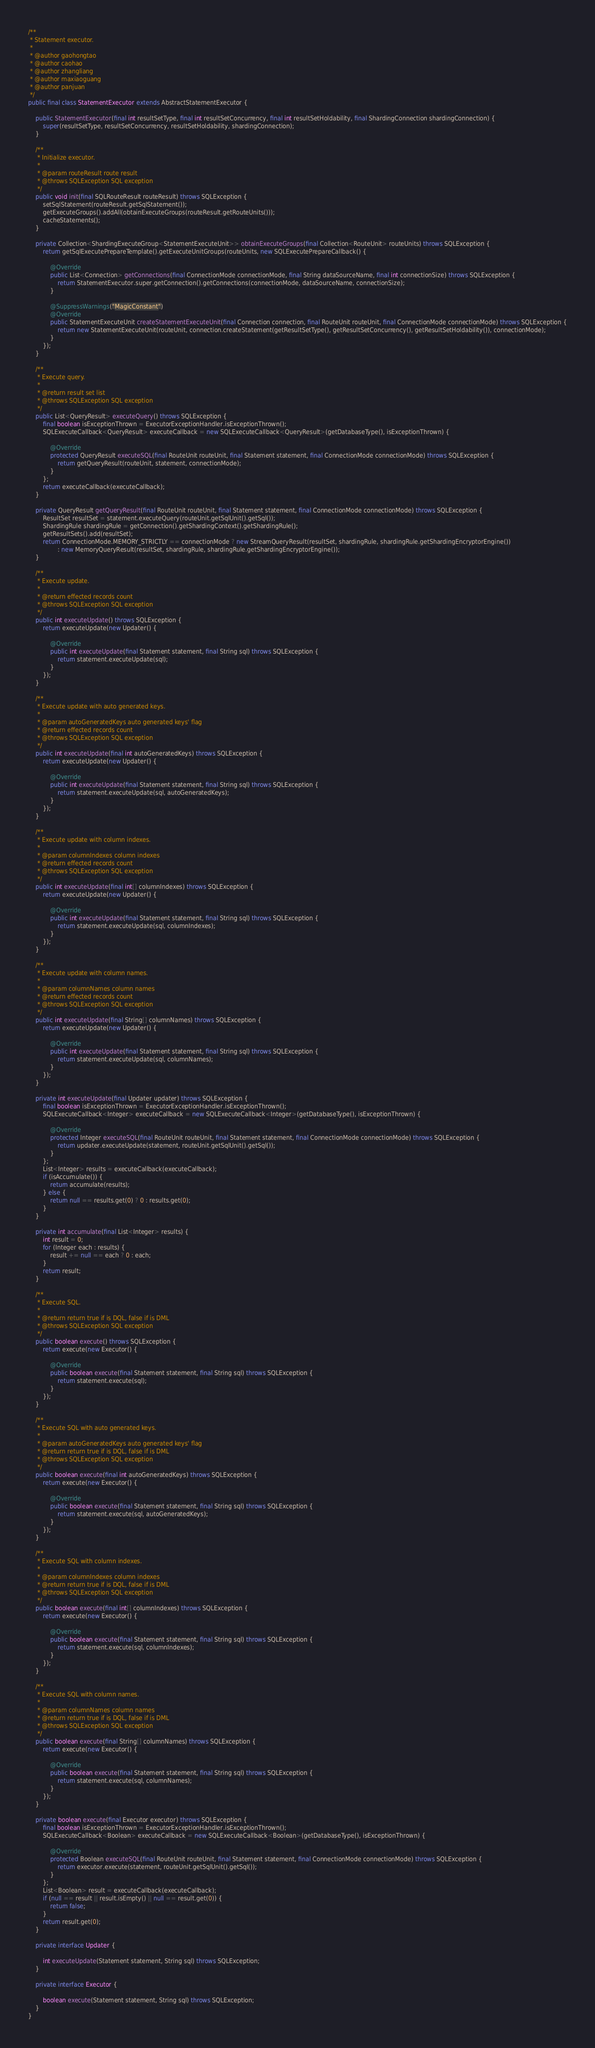<code> <loc_0><loc_0><loc_500><loc_500><_Java_>/**
 * Statement executor.
 * 
 * @author gaohongtao
 * @author caohao
 * @author zhangliang
 * @author maxiaoguang
 * @author panjuan
 */
public final class StatementExecutor extends AbstractStatementExecutor {
    
    public StatementExecutor(final int resultSetType, final int resultSetConcurrency, final int resultSetHoldability, final ShardingConnection shardingConnection) {
        super(resultSetType, resultSetConcurrency, resultSetHoldability, shardingConnection);
    }
    
    /**
     * Initialize executor.
     *
     * @param routeResult route result
     * @throws SQLException SQL exception
     */
    public void init(final SQLRouteResult routeResult) throws SQLException {
        setSqlStatement(routeResult.getSqlStatement());
        getExecuteGroups().addAll(obtainExecuteGroups(routeResult.getRouteUnits()));
        cacheStatements();
    }
    
    private Collection<ShardingExecuteGroup<StatementExecuteUnit>> obtainExecuteGroups(final Collection<RouteUnit> routeUnits) throws SQLException {
        return getSqlExecutePrepareTemplate().getExecuteUnitGroups(routeUnits, new SQLExecutePrepareCallback() {
            
            @Override
            public List<Connection> getConnections(final ConnectionMode connectionMode, final String dataSourceName, final int connectionSize) throws SQLException {
                return StatementExecutor.super.getConnection().getConnections(connectionMode, dataSourceName, connectionSize);
            }
    
            @SuppressWarnings("MagicConstant")
            @Override
            public StatementExecuteUnit createStatementExecuteUnit(final Connection connection, final RouteUnit routeUnit, final ConnectionMode connectionMode) throws SQLException {
                return new StatementExecuteUnit(routeUnit, connection.createStatement(getResultSetType(), getResultSetConcurrency(), getResultSetHoldability()), connectionMode);
            }
        });
    }
    
    /**
     * Execute query.
     * 
     * @return result set list
     * @throws SQLException SQL exception
     */
    public List<QueryResult> executeQuery() throws SQLException {
        final boolean isExceptionThrown = ExecutorExceptionHandler.isExceptionThrown();
        SQLExecuteCallback<QueryResult> executeCallback = new SQLExecuteCallback<QueryResult>(getDatabaseType(), isExceptionThrown) {
            
            @Override
            protected QueryResult executeSQL(final RouteUnit routeUnit, final Statement statement, final ConnectionMode connectionMode) throws SQLException {
                return getQueryResult(routeUnit, statement, connectionMode);
            }
        };
        return executeCallback(executeCallback);
    }
    
    private QueryResult getQueryResult(final RouteUnit routeUnit, final Statement statement, final ConnectionMode connectionMode) throws SQLException {
        ResultSet resultSet = statement.executeQuery(routeUnit.getSqlUnit().getSql());
        ShardingRule shardingRule = getConnection().getShardingContext().getShardingRule();
        getResultSets().add(resultSet);
        return ConnectionMode.MEMORY_STRICTLY == connectionMode ? new StreamQueryResult(resultSet, shardingRule, shardingRule.getShardingEncryptorEngine()) 
                : new MemoryQueryResult(resultSet, shardingRule, shardingRule.getShardingEncryptorEngine());
    }
    
    /**
     * Execute update.
     * 
     * @return effected records count
     * @throws SQLException SQL exception
     */
    public int executeUpdate() throws SQLException {
        return executeUpdate(new Updater() {
            
            @Override
            public int executeUpdate(final Statement statement, final String sql) throws SQLException {
                return statement.executeUpdate(sql);
            }
        });
    }
    
    /**
     * Execute update with auto generated keys.
     * 
     * @param autoGeneratedKeys auto generated keys' flag
     * @return effected records count
     * @throws SQLException SQL exception
     */
    public int executeUpdate(final int autoGeneratedKeys) throws SQLException {
        return executeUpdate(new Updater() {
            
            @Override
            public int executeUpdate(final Statement statement, final String sql) throws SQLException {
                return statement.executeUpdate(sql, autoGeneratedKeys);
            }
        });
    }
    
    /**
     * Execute update with column indexes.
     *
     * @param columnIndexes column indexes
     * @return effected records count
     * @throws SQLException SQL exception
     */
    public int executeUpdate(final int[] columnIndexes) throws SQLException {
        return executeUpdate(new Updater() {
            
            @Override
            public int executeUpdate(final Statement statement, final String sql) throws SQLException {
                return statement.executeUpdate(sql, columnIndexes);
            }
        });
    }
    
    /**
     * Execute update with column names.
     *
     * @param columnNames column names
     * @return effected records count
     * @throws SQLException SQL exception
     */
    public int executeUpdate(final String[] columnNames) throws SQLException {
        return executeUpdate(new Updater() {
            
            @Override
            public int executeUpdate(final Statement statement, final String sql) throws SQLException {
                return statement.executeUpdate(sql, columnNames);
            }
        });
    }
    
    private int executeUpdate(final Updater updater) throws SQLException {
        final boolean isExceptionThrown = ExecutorExceptionHandler.isExceptionThrown();
        SQLExecuteCallback<Integer> executeCallback = new SQLExecuteCallback<Integer>(getDatabaseType(), isExceptionThrown) {
            
            @Override
            protected Integer executeSQL(final RouteUnit routeUnit, final Statement statement, final ConnectionMode connectionMode) throws SQLException {
                return updater.executeUpdate(statement, routeUnit.getSqlUnit().getSql());
            }
        };
        List<Integer> results = executeCallback(executeCallback);
        if (isAccumulate()) {
            return accumulate(results);
        } else {
            return null == results.get(0) ? 0 : results.get(0);
        }
    }
    
    private int accumulate(final List<Integer> results) {
        int result = 0;
        for (Integer each : results) {
            result += null == each ? 0 : each;
        }
        return result;
    }
    
    /**
     * Execute SQL.
     *
     * @return return true if is DQL, false if is DML
     * @throws SQLException SQL exception
     */
    public boolean execute() throws SQLException {
        return execute(new Executor() {
            
            @Override
            public boolean execute(final Statement statement, final String sql) throws SQLException {
                return statement.execute(sql);
            }
        });
    }
    
    /**
     * Execute SQL with auto generated keys.
     *
     * @param autoGeneratedKeys auto generated keys' flag
     * @return return true if is DQL, false if is DML
     * @throws SQLException SQL exception
     */
    public boolean execute(final int autoGeneratedKeys) throws SQLException {
        return execute(new Executor() {
            
            @Override
            public boolean execute(final Statement statement, final String sql) throws SQLException {
                return statement.execute(sql, autoGeneratedKeys);
            }
        });
    }
    
    /**
     * Execute SQL with column indexes.
     *
     * @param columnIndexes column indexes
     * @return return true if is DQL, false if is DML
     * @throws SQLException SQL exception
     */
    public boolean execute(final int[] columnIndexes) throws SQLException {
        return execute(new Executor() {
            
            @Override
            public boolean execute(final Statement statement, final String sql) throws SQLException {
                return statement.execute(sql, columnIndexes);
            }
        });
    }
    
    /**
     * Execute SQL with column names.
     *
     * @param columnNames column names
     * @return return true if is DQL, false if is DML
     * @throws SQLException SQL exception
     */
    public boolean execute(final String[] columnNames) throws SQLException {
        return execute(new Executor() {
            
            @Override
            public boolean execute(final Statement statement, final String sql) throws SQLException {
                return statement.execute(sql, columnNames);
            }
        });
    }
    
    private boolean execute(final Executor executor) throws SQLException {
        final boolean isExceptionThrown = ExecutorExceptionHandler.isExceptionThrown();
        SQLExecuteCallback<Boolean> executeCallback = new SQLExecuteCallback<Boolean>(getDatabaseType(), isExceptionThrown) {
            
            @Override
            protected Boolean executeSQL(final RouteUnit routeUnit, final Statement statement, final ConnectionMode connectionMode) throws SQLException {
                return executor.execute(statement, routeUnit.getSqlUnit().getSql());
            }
        };
        List<Boolean> result = executeCallback(executeCallback);
        if (null == result || result.isEmpty() || null == result.get(0)) {
            return false;
        }
        return result.get(0);
    }
    
    private interface Updater {
        
        int executeUpdate(Statement statement, String sql) throws SQLException;
    }
    
    private interface Executor {
        
        boolean execute(Statement statement, String sql) throws SQLException;
    }
}

</code> 